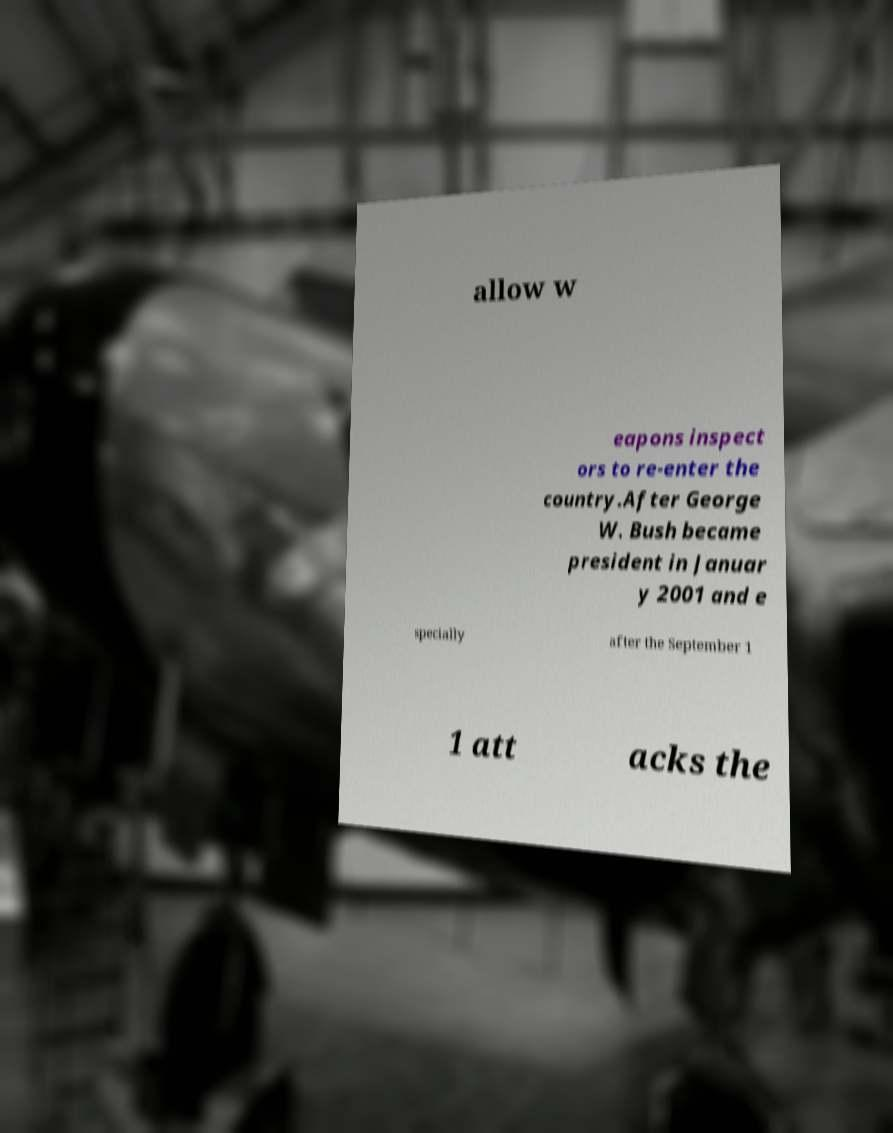Please identify and transcribe the text found in this image. allow w eapons inspect ors to re-enter the country.After George W. Bush became president in Januar y 2001 and e specially after the September 1 1 att acks the 